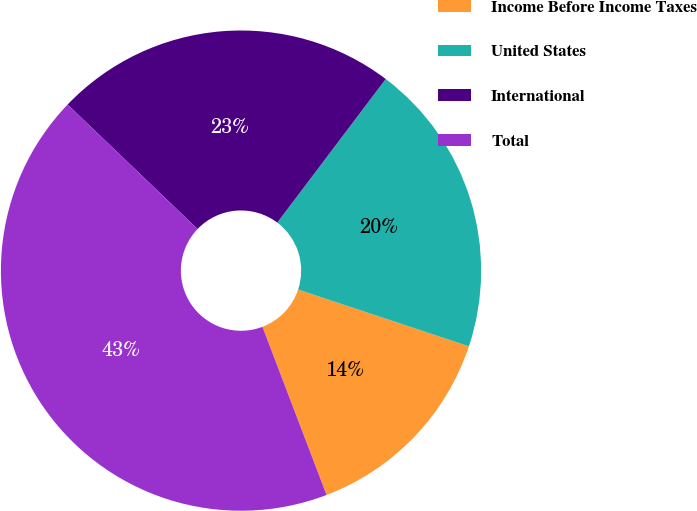Convert chart. <chart><loc_0><loc_0><loc_500><loc_500><pie_chart><fcel>Income Before Income Taxes<fcel>United States<fcel>International<fcel>Total<nl><fcel>14.1%<fcel>19.81%<fcel>23.14%<fcel>42.95%<nl></chart> 